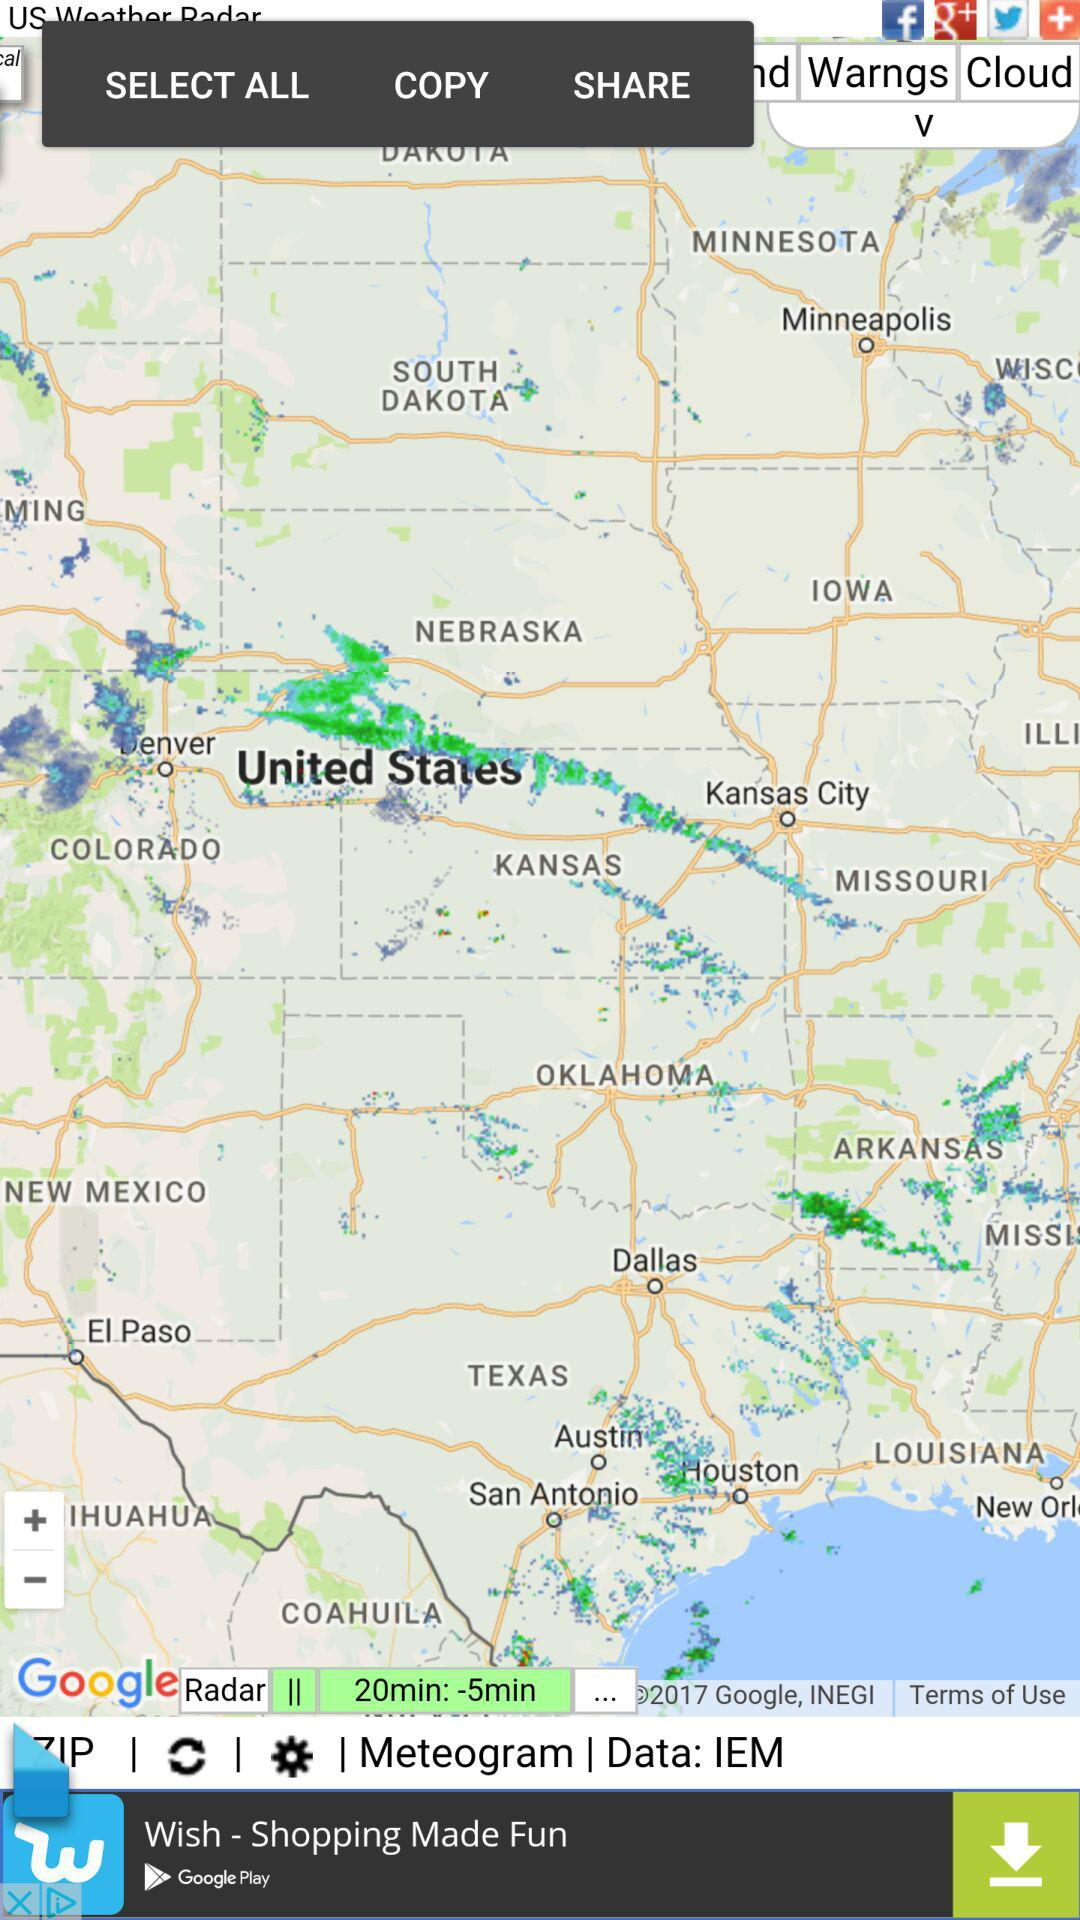To which country do all these cities belong? All these countries belong to the United States. 